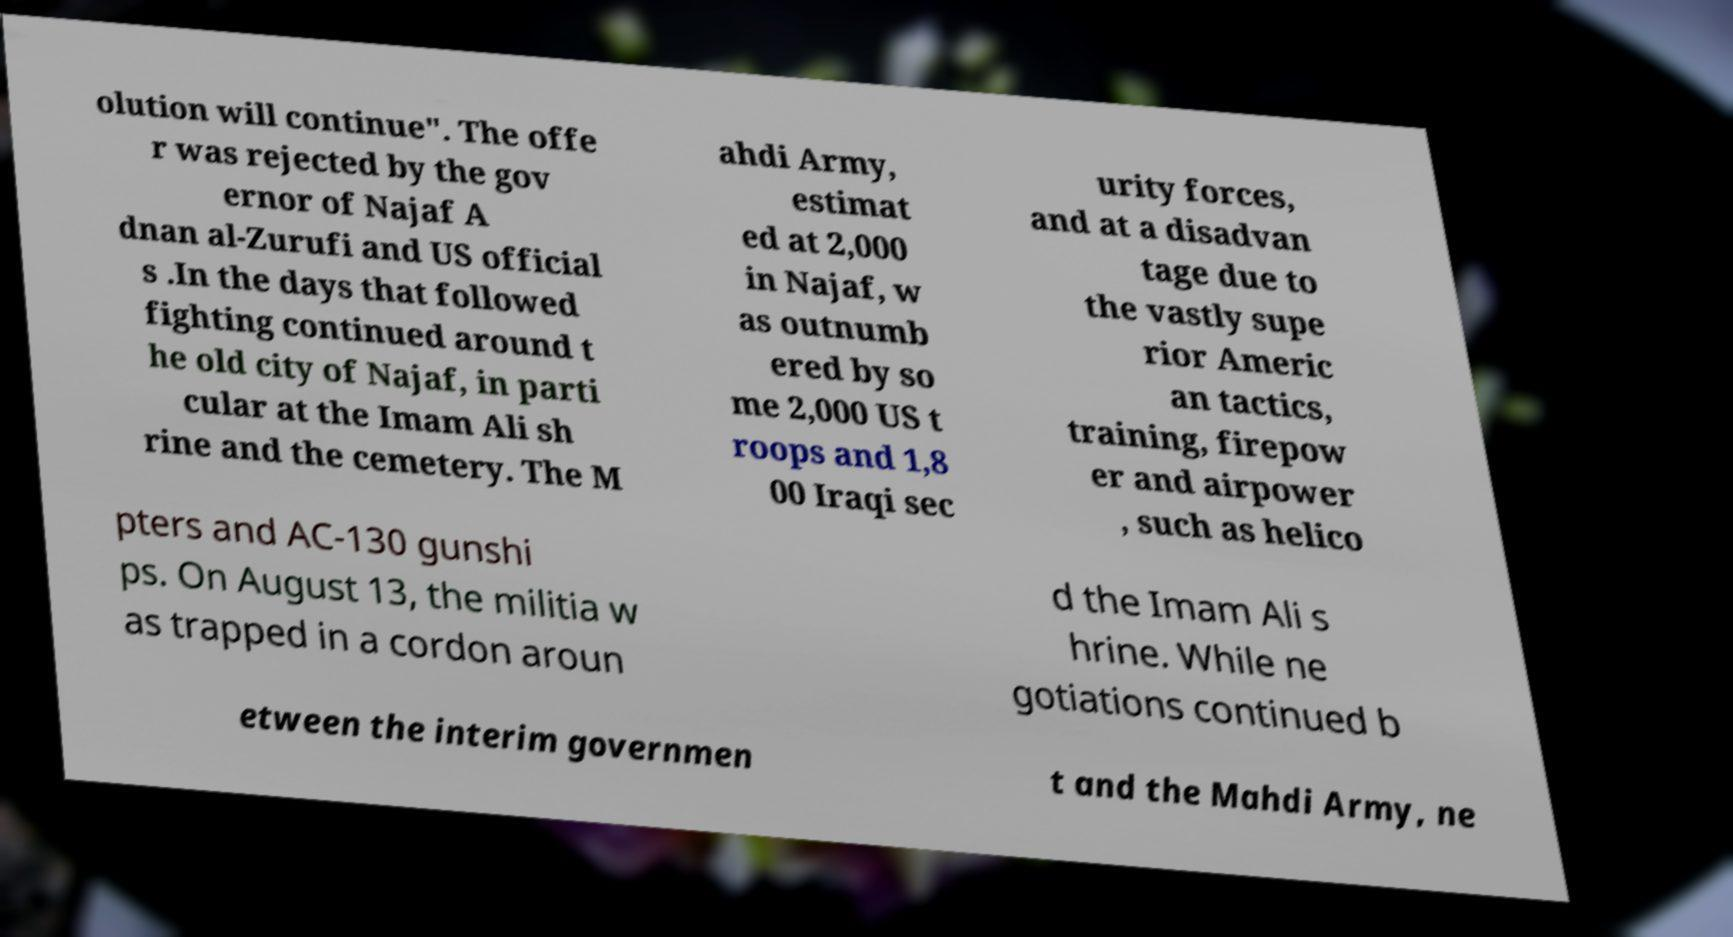Could you extract and type out the text from this image? olution will continue". The offe r was rejected by the gov ernor of Najaf A dnan al-Zurufi and US official s .In the days that followed fighting continued around t he old city of Najaf, in parti cular at the Imam Ali sh rine and the cemetery. The M ahdi Army, estimat ed at 2,000 in Najaf, w as outnumb ered by so me 2,000 US t roops and 1,8 00 Iraqi sec urity forces, and at a disadvan tage due to the vastly supe rior Americ an tactics, training, firepow er and airpower , such as helico pters and AC-130 gunshi ps. On August 13, the militia w as trapped in a cordon aroun d the Imam Ali s hrine. While ne gotiations continued b etween the interim governmen t and the Mahdi Army, ne 